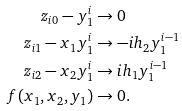<formula> <loc_0><loc_0><loc_500><loc_500>z _ { i 0 } - y _ { 1 } ^ { i } & \to 0 \\ z _ { i 1 } - x _ { 1 } y _ { 1 } ^ { i } & \to - i h _ { 2 } y _ { 1 } ^ { i - 1 } \\ z _ { i 2 } - x _ { 2 } y _ { 1 } ^ { i } & \to i h _ { 1 } y _ { 1 } ^ { i - 1 } \\ f ( x _ { 1 } , x _ { 2 } , y _ { 1 } ) & \to 0 .</formula> 